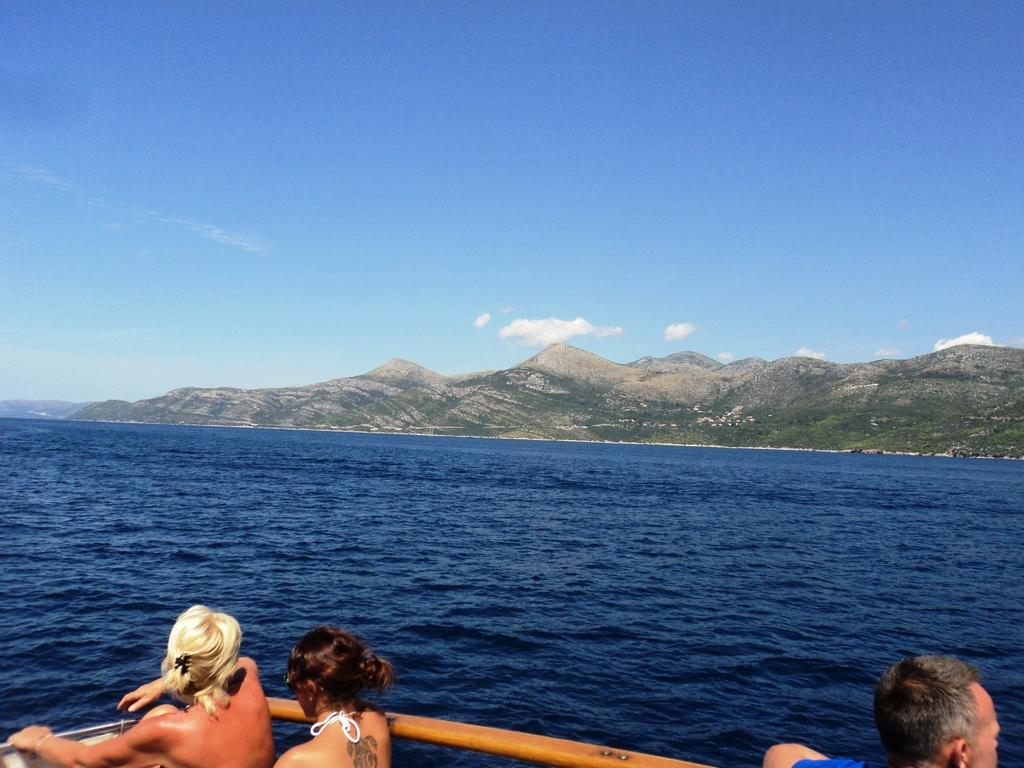What can be seen in the foreground of the picture? There are people standing near the railing in the foreground of the picture. What is located in the center of the picture? There are hills and water in the center of the picture. What is the condition of the sky in the picture? The sky is clear in the picture. What is the weather like in the image? It is sunny in the image. What color is the straw in the picture? There is no straw present in the image. What type of record can be seen being played in the picture? There is no record player or record visible in the image. 